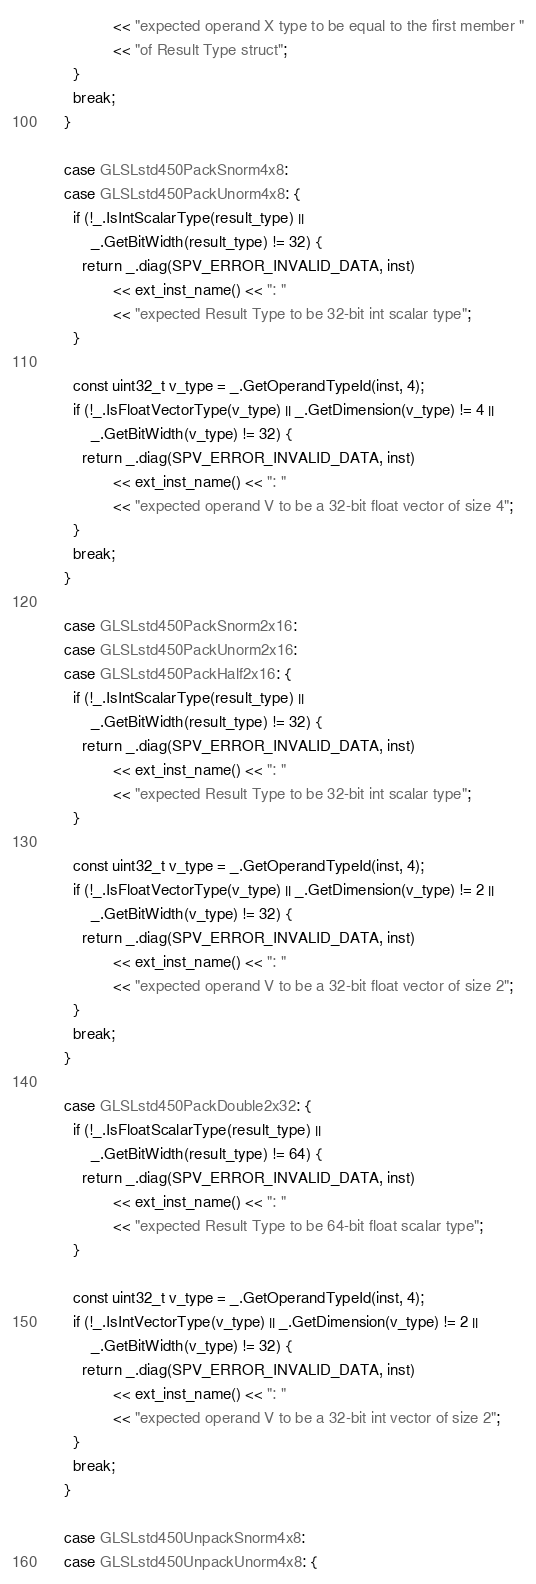<code> <loc_0><loc_0><loc_500><loc_500><_C++_>                 << "expected operand X type to be equal to the first member "
                 << "of Result Type struct";
        }
        break;
      }

      case GLSLstd450PackSnorm4x8:
      case GLSLstd450PackUnorm4x8: {
        if (!_.IsIntScalarType(result_type) ||
            _.GetBitWidth(result_type) != 32) {
          return _.diag(SPV_ERROR_INVALID_DATA, inst)
                 << ext_inst_name() << ": "
                 << "expected Result Type to be 32-bit int scalar type";
        }

        const uint32_t v_type = _.GetOperandTypeId(inst, 4);
        if (!_.IsFloatVectorType(v_type) || _.GetDimension(v_type) != 4 ||
            _.GetBitWidth(v_type) != 32) {
          return _.diag(SPV_ERROR_INVALID_DATA, inst)
                 << ext_inst_name() << ": "
                 << "expected operand V to be a 32-bit float vector of size 4";
        }
        break;
      }

      case GLSLstd450PackSnorm2x16:
      case GLSLstd450PackUnorm2x16:
      case GLSLstd450PackHalf2x16: {
        if (!_.IsIntScalarType(result_type) ||
            _.GetBitWidth(result_type) != 32) {
          return _.diag(SPV_ERROR_INVALID_DATA, inst)
                 << ext_inst_name() << ": "
                 << "expected Result Type to be 32-bit int scalar type";
        }

        const uint32_t v_type = _.GetOperandTypeId(inst, 4);
        if (!_.IsFloatVectorType(v_type) || _.GetDimension(v_type) != 2 ||
            _.GetBitWidth(v_type) != 32) {
          return _.diag(SPV_ERROR_INVALID_DATA, inst)
                 << ext_inst_name() << ": "
                 << "expected operand V to be a 32-bit float vector of size 2";
        }
        break;
      }

      case GLSLstd450PackDouble2x32: {
        if (!_.IsFloatScalarType(result_type) ||
            _.GetBitWidth(result_type) != 64) {
          return _.diag(SPV_ERROR_INVALID_DATA, inst)
                 << ext_inst_name() << ": "
                 << "expected Result Type to be 64-bit float scalar type";
        }

        const uint32_t v_type = _.GetOperandTypeId(inst, 4);
        if (!_.IsIntVectorType(v_type) || _.GetDimension(v_type) != 2 ||
            _.GetBitWidth(v_type) != 32) {
          return _.diag(SPV_ERROR_INVALID_DATA, inst)
                 << ext_inst_name() << ": "
                 << "expected operand V to be a 32-bit int vector of size 2";
        }
        break;
      }

      case GLSLstd450UnpackSnorm4x8:
      case GLSLstd450UnpackUnorm4x8: {</code> 